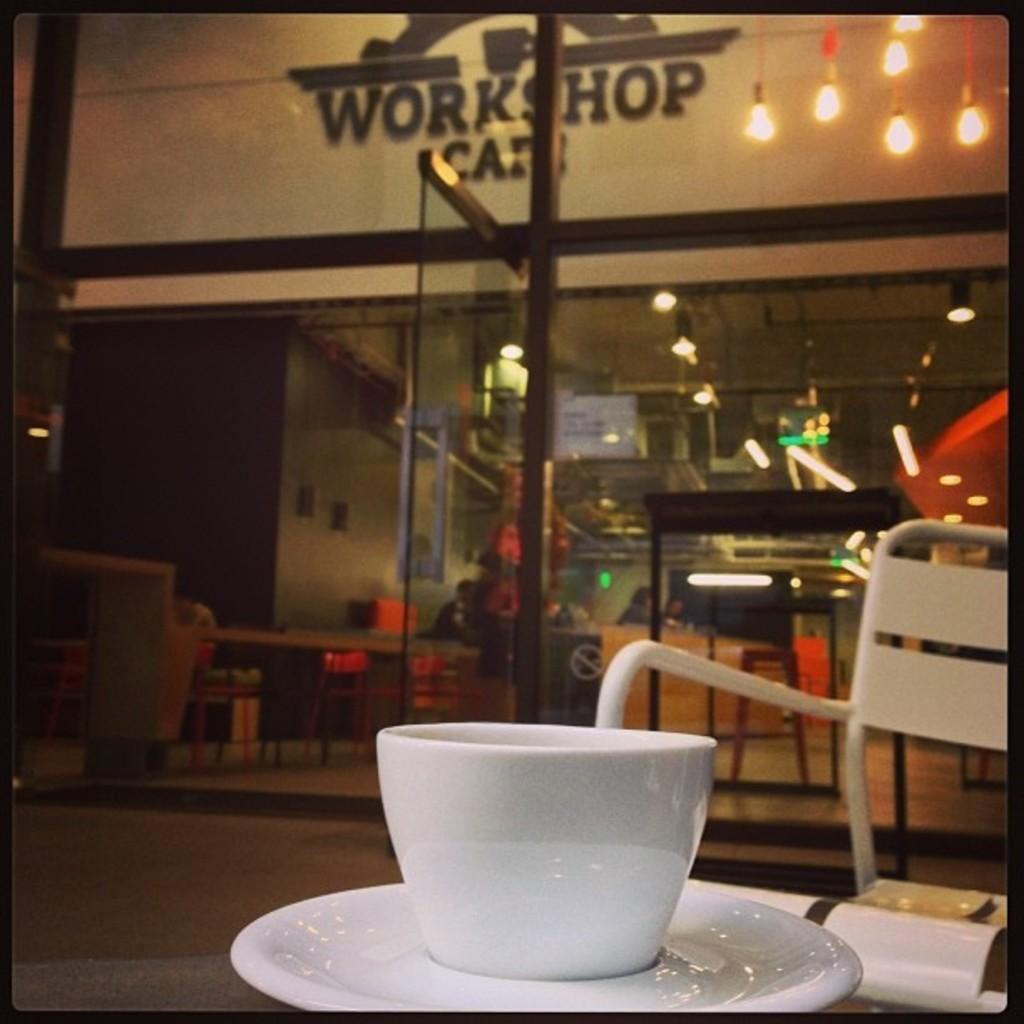<image>
Share a concise interpretation of the image provided. A cup and a plate in front of workshop cafe.. 